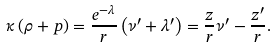<formula> <loc_0><loc_0><loc_500><loc_500>\kappa \left ( \rho + p \right ) = \frac { e ^ { - \lambda } } r \left ( \nu ^ { \prime } + \lambda ^ { \prime } \right ) = \frac { z } { r } \nu ^ { \prime } - \frac { z ^ { \prime } } r .</formula> 